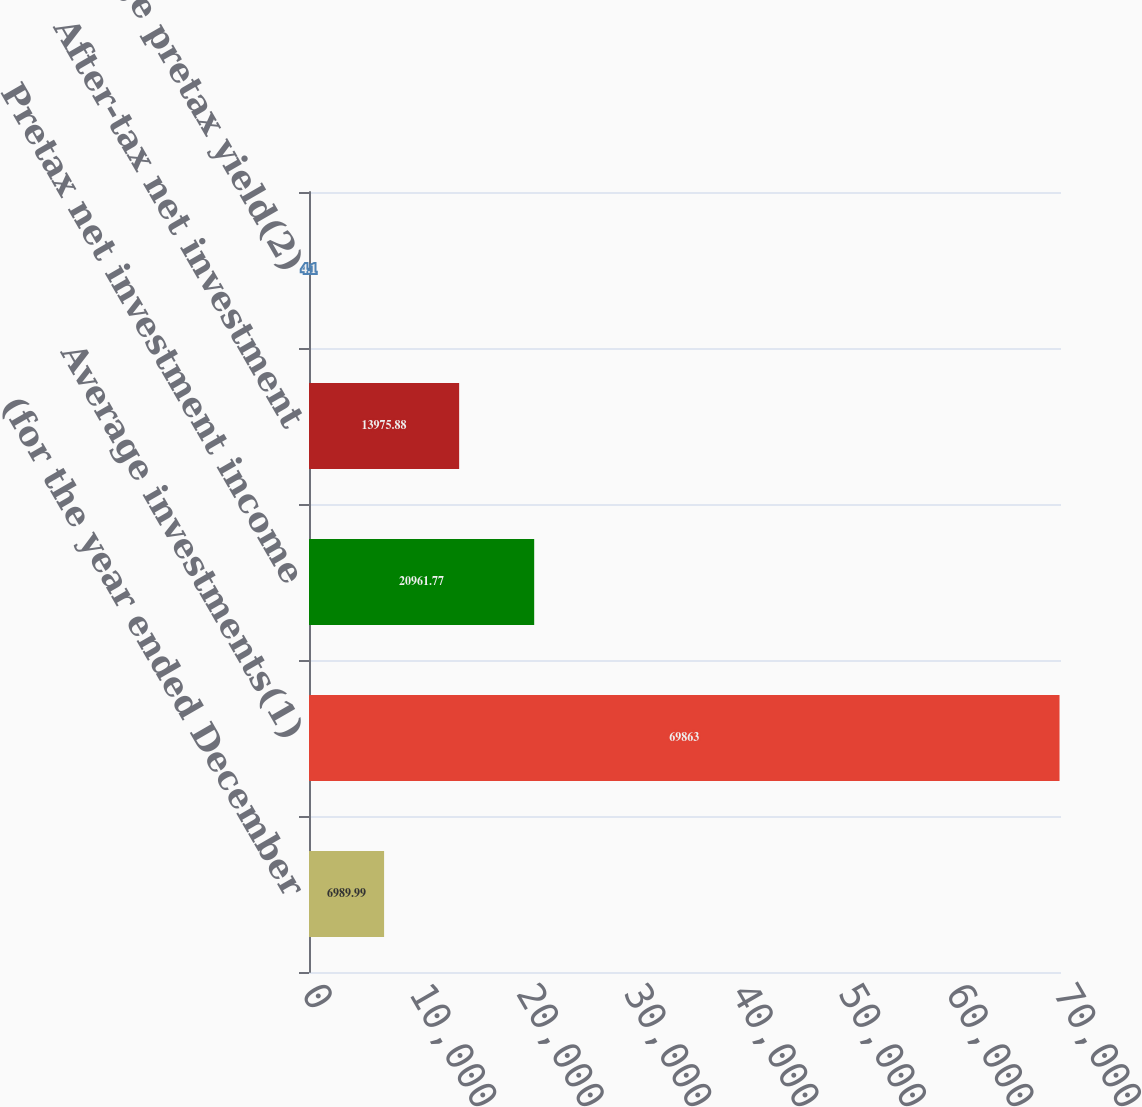Convert chart. <chart><loc_0><loc_0><loc_500><loc_500><bar_chart><fcel>(for the year ended December<fcel>Average investments(1)<fcel>Pretax net investment income<fcel>After-tax net investment<fcel>Average pretax yield(2)<nl><fcel>6989.99<fcel>69863<fcel>20961.8<fcel>13975.9<fcel>4.1<nl></chart> 